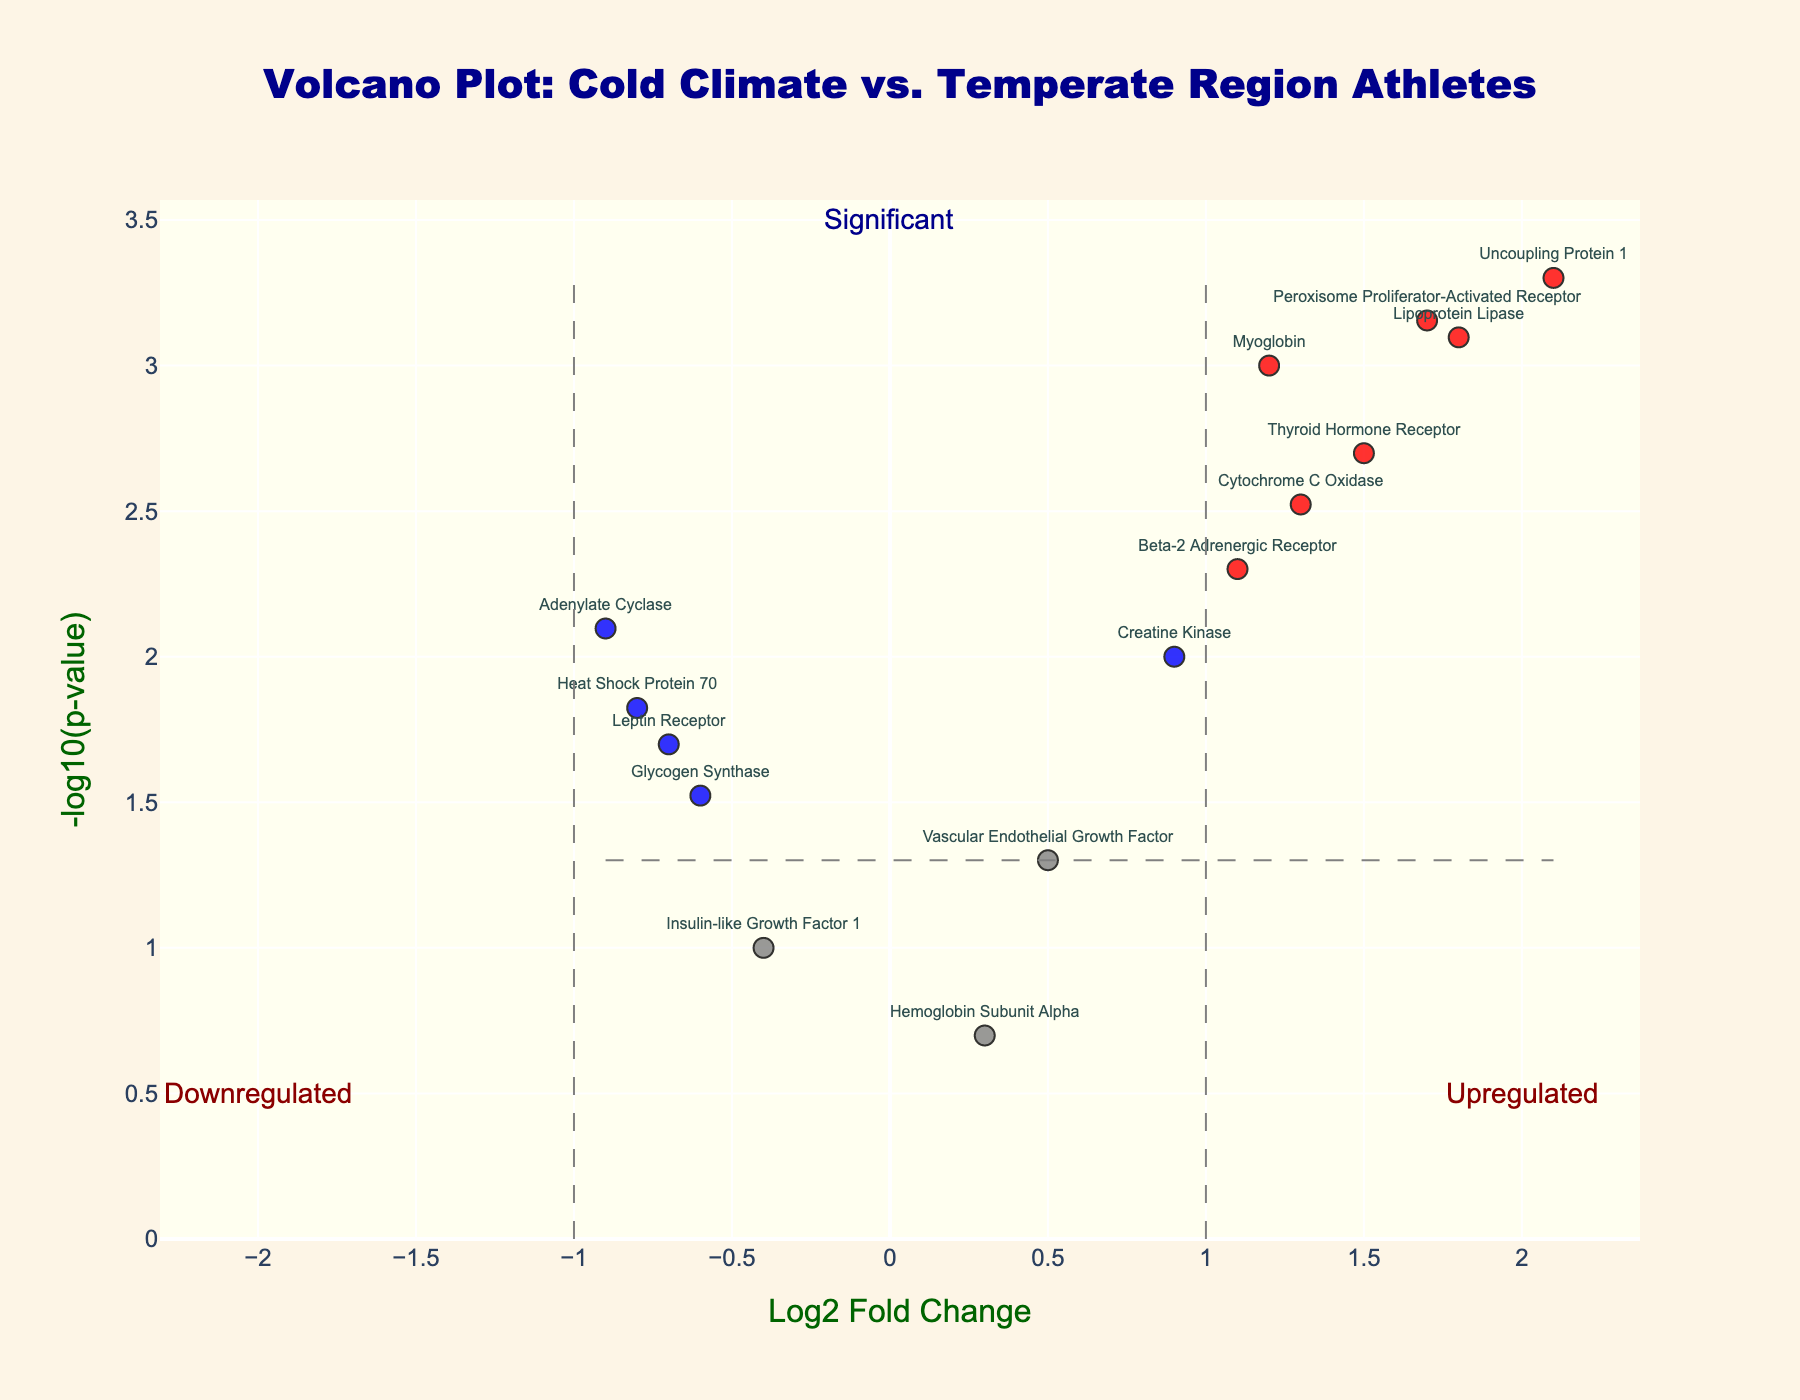Which protein has the highest log2 fold change? Reviewing the horizontal axis, Uncoupling Protein 1 is positioned farthest to the right, indicating the highest log2 fold change.
Answer: Uncoupling Protein 1 What is the significance threshold for the p-value in this plot? By checking the annotation or the horizontal line placed near the top of the plot, we find the p-value significance threshold. It's aligned with -log10(p-value)=1.301, corresponding to p-value = 0.05.
Answer: 0.05 Which two proteins have similar p-values but different log2 fold changes, being situated near the significance threshold? Observing the points around the horizontal significance line, Vascular Endothelial Growth Factor and Hemoglobin Subunit Alpha have similar p-values but different log2 fold changes.
Answer: Vascular Endothelial Growth Factor, Hemoglobin Subunit Alpha Which protein is indicated as downregulated and is marked in blue? We look for a protein with a negative log2 fold change below 1 and a significant p-value less than 0.05; Heat Shock Protein 70 fits this description.
Answer: Heat Shock Protein 70 How many upregulated proteins are significant (marked in red)? By counting the red-marked data points with positive log2 fold change, we find six upregulated proteins significant.
Answer: 6 Which protein has the lowest p-value among its group? Uncoupling Protein 1 appears highest along the vertical axis, indicating the smallest p-value.
Answer: Uncoupling Protein 1 Considering only green-marked proteins, which one has a lower p-value, Thyroid Hormone Receptor or Creatine Kinase? Observing their respective y-values suggests that Thyroid Hormone Receptor has a higher -log10(p-value) than Creatine Kinase, indicating a lower p-value.
Answer: Thyroid Hormone Receptor What is the log2 fold change range depicted in this plot? The x-axis ranges approximately from -1 to +2 for the log2 fold changes based on the plot boundaries.
Answer: -1 to +2 